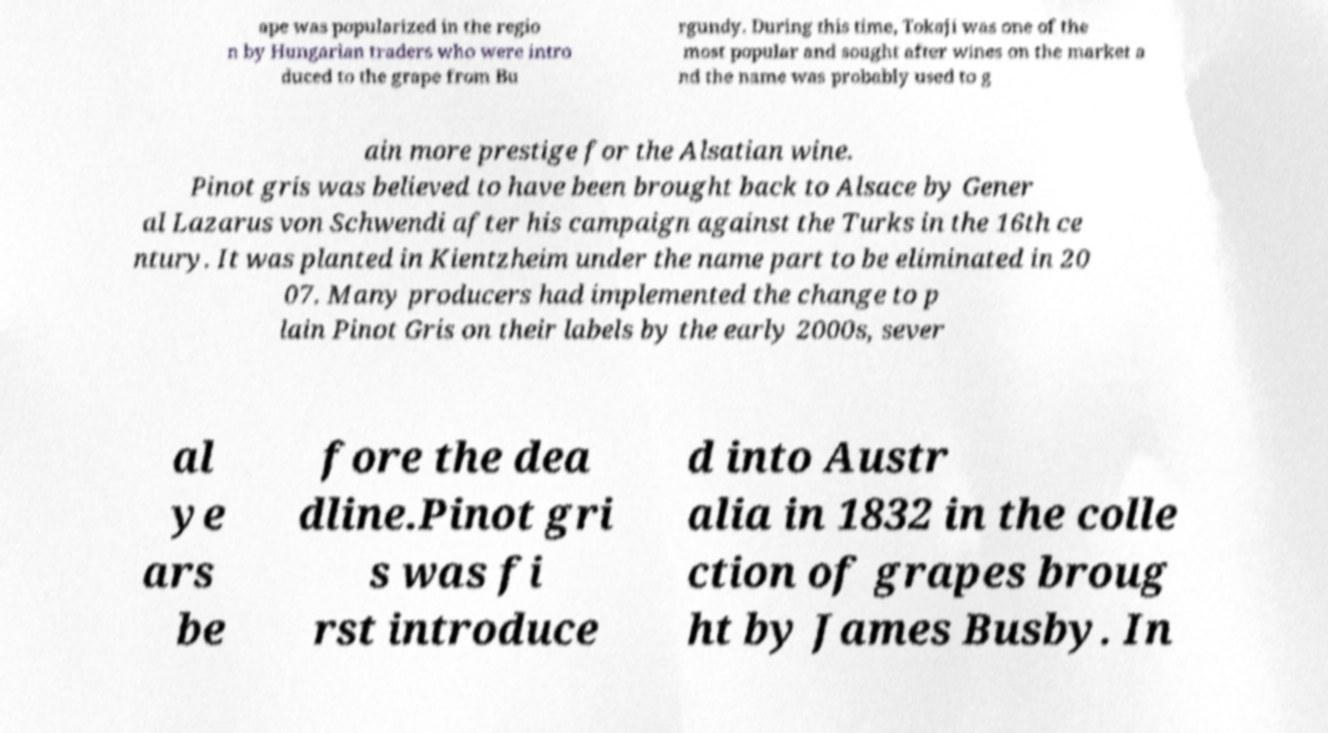There's text embedded in this image that I need extracted. Can you transcribe it verbatim? ape was popularized in the regio n by Hungarian traders who were intro duced to the grape from Bu rgundy. During this time, Tokaji was one of the most popular and sought after wines on the market a nd the name was probably used to g ain more prestige for the Alsatian wine. Pinot gris was believed to have been brought back to Alsace by Gener al Lazarus von Schwendi after his campaign against the Turks in the 16th ce ntury. It was planted in Kientzheim under the name part to be eliminated in 20 07. Many producers had implemented the change to p lain Pinot Gris on their labels by the early 2000s, sever al ye ars be fore the dea dline.Pinot gri s was fi rst introduce d into Austr alia in 1832 in the colle ction of grapes broug ht by James Busby. In 